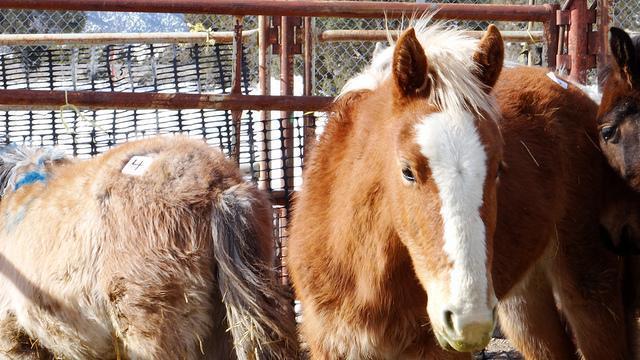How many horses are shown?
Give a very brief answer. 3. How many horses are there?
Give a very brief answer. 3. How many people are wearing blue?
Give a very brief answer. 0. 